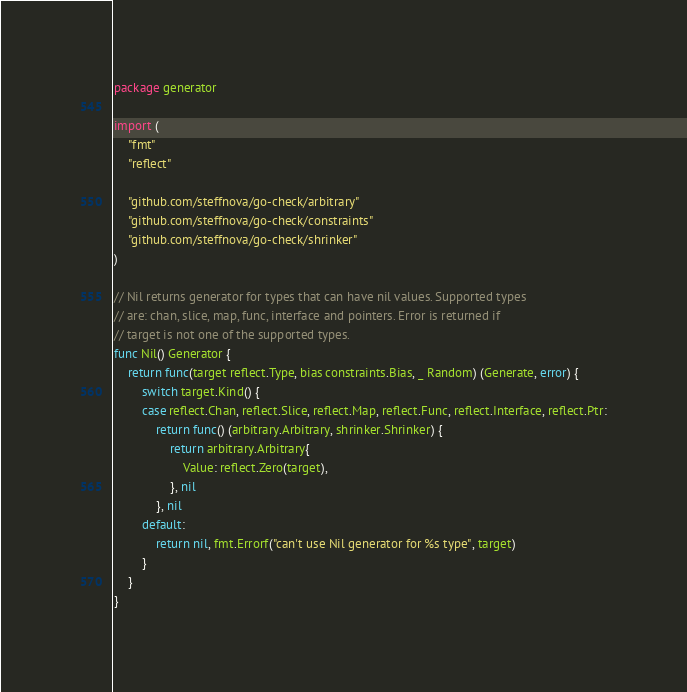<code> <loc_0><loc_0><loc_500><loc_500><_Go_>package generator

import (
	"fmt"
	"reflect"

	"github.com/steffnova/go-check/arbitrary"
	"github.com/steffnova/go-check/constraints"
	"github.com/steffnova/go-check/shrinker"
)

// Nil returns generator for types that can have nil values. Supported types
// are: chan, slice, map, func, interface and pointers. Error is returned if
// target is not one of the supported types.
func Nil() Generator {
	return func(target reflect.Type, bias constraints.Bias, _ Random) (Generate, error) {
		switch target.Kind() {
		case reflect.Chan, reflect.Slice, reflect.Map, reflect.Func, reflect.Interface, reflect.Ptr:
			return func() (arbitrary.Arbitrary, shrinker.Shrinker) {
				return arbitrary.Arbitrary{
					Value: reflect.Zero(target),
				}, nil
			}, nil
		default:
			return nil, fmt.Errorf("can't use Nil generator for %s type", target)
		}
	}
}
</code> 